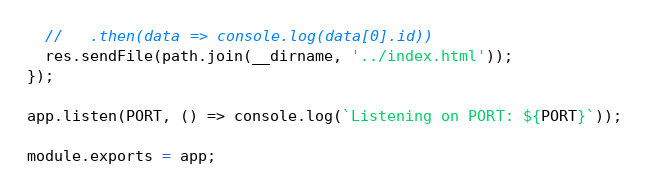<code> <loc_0><loc_0><loc_500><loc_500><_JavaScript_>  //   .then(data => console.log(data[0].id))
  res.sendFile(path.join(__dirname, '../index.html'));
});

app.listen(PORT, () => console.log(`Listening on PORT: ${PORT}`));

module.exports = app;
</code> 